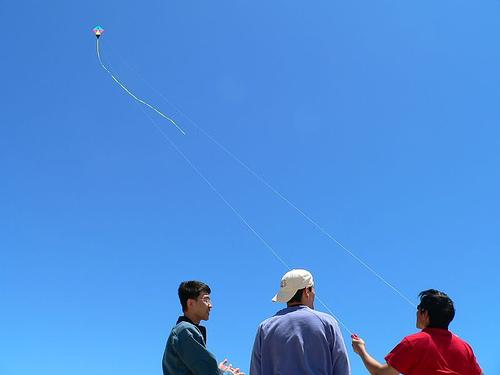Which color shirt does the person flying the kite wear?

Choices:
A) green
B) lavender
C) red
D) teal red 